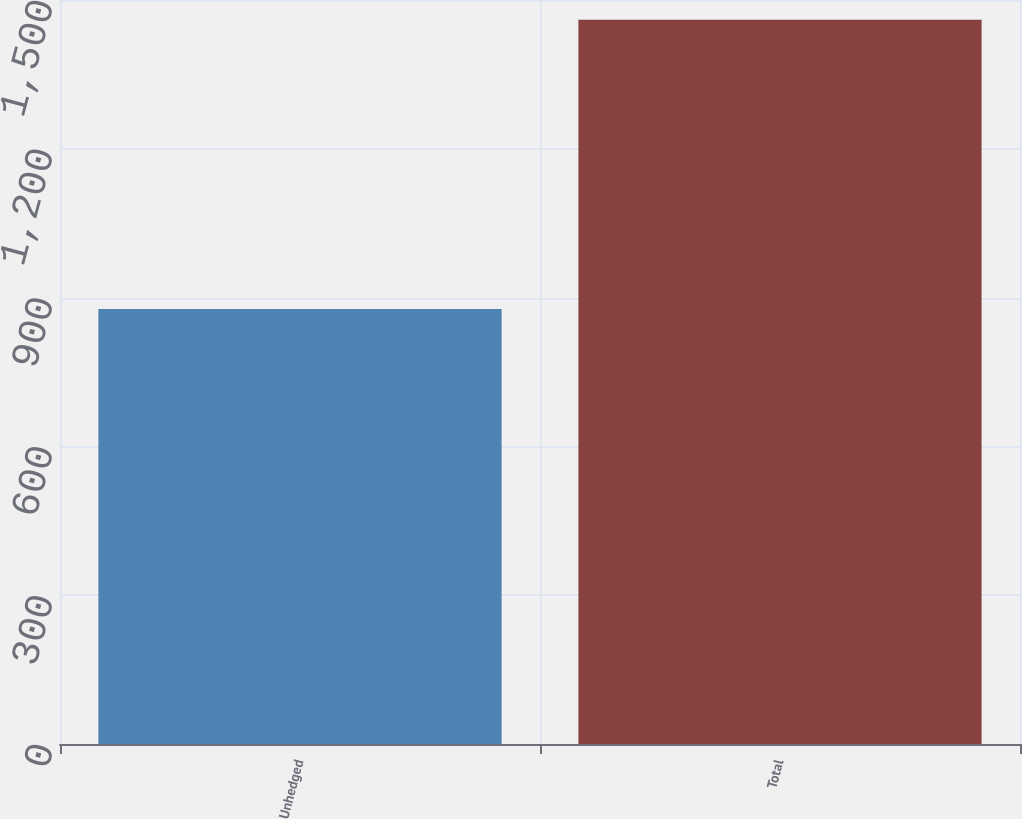Convert chart. <chart><loc_0><loc_0><loc_500><loc_500><bar_chart><fcel>Unhedged<fcel>Total<nl><fcel>877<fcel>1460<nl></chart> 